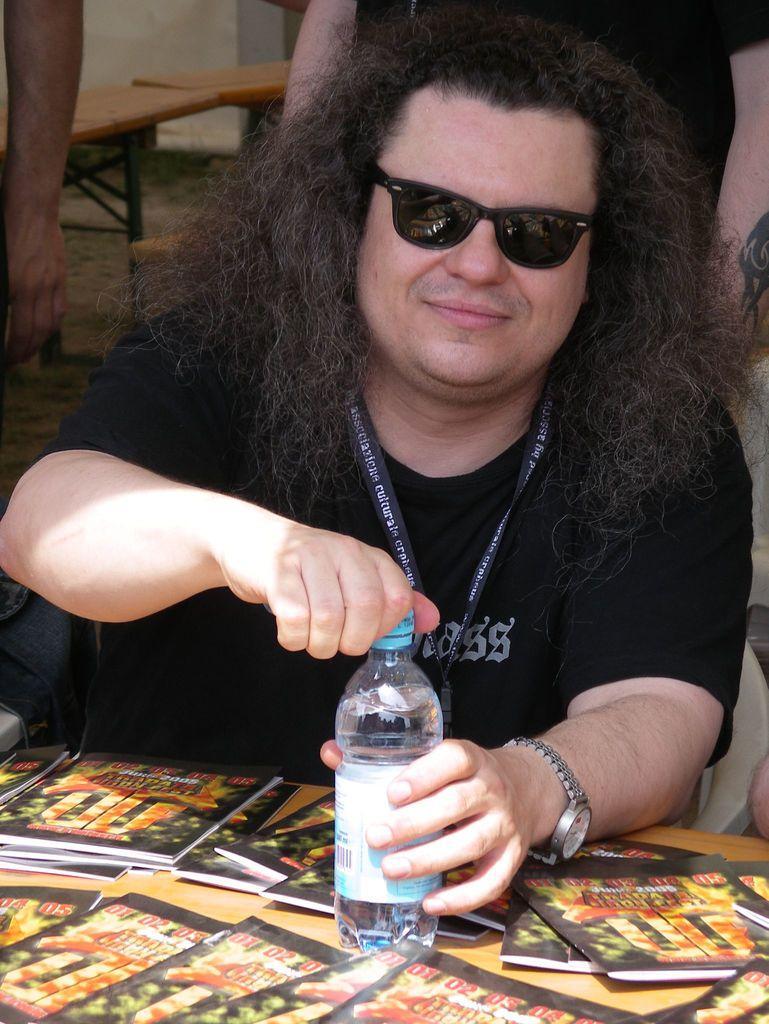Describe this image in one or two sentences. In this image In the middle there is a man he is smiling he wear black t shirt, watch and shades he is opening bottle cap. At the bottom there is a table on that there are many books. In the background there are some people and table. 